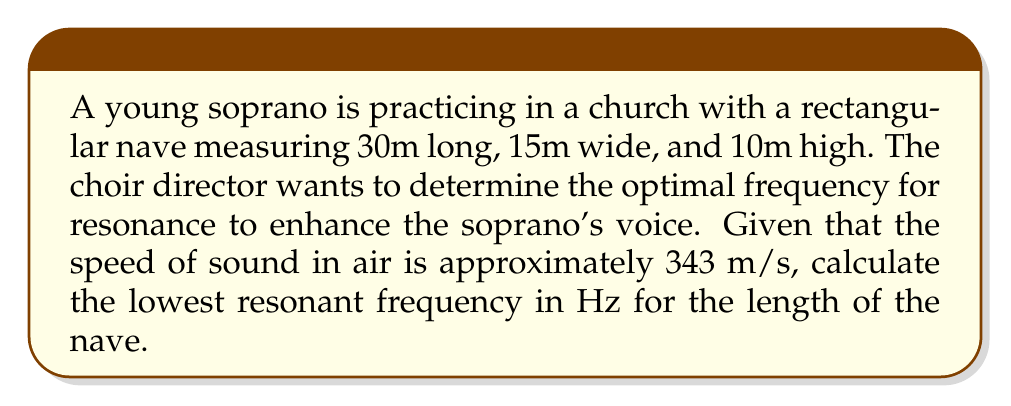Can you solve this math problem? To solve this problem, we'll use the concept of standing waves in a rectangular cavity (the church nave) and apply it to sound waves.

Step 1: Identify the relevant equation
For a rectangular cavity, the resonant frequencies are given by:

$$f = \frac{c}{2} \sqrt{\left(\frac{n_x}{L_x}\right)^2 + \left(\frac{n_y}{L_y}\right)^2 + \left(\frac{n_z}{L_z}\right)^2}$$

Where:
$f$ is the resonant frequency
$c$ is the speed of sound
$L_x$, $L_y$, and $L_z$ are the dimensions of the cavity
$n_x$, $n_y$, and $n_z$ are integers representing the mode numbers

Step 2: Determine the lowest resonant frequency
The lowest resonant frequency occurs when $n_x = 1$ and $n_y = n_z = 0$. This corresponds to the fundamental mode along the longest dimension (length) of the nave.

Step 3: Simplify the equation for this case
$$f = \frac{c}{2L_x}$$

Step 4: Substitute the known values
$c = 343$ m/s
$L_x = 30$ m

$$f = \frac{343}{2 \cdot 30}$$

Step 5: Calculate the result
$$f = \frac{343}{60} = 5.7166... \text{ Hz}$$

Step 6: Round to two decimal places
$f \approx 5.72$ Hz
Answer: 5.72 Hz 